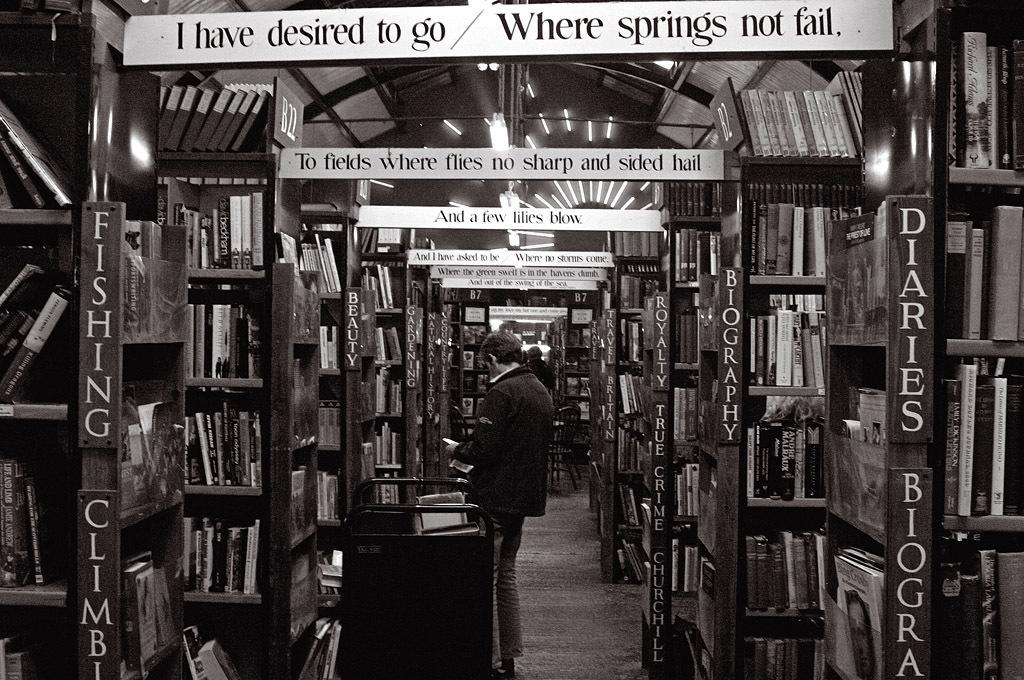Where do you have a desire to go?
Keep it short and to the point. Where springs not fail. Do they have a diary section?
Keep it short and to the point. Yes. 